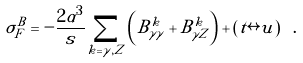Convert formula to latex. <formula><loc_0><loc_0><loc_500><loc_500>\sigma ^ { B } _ { F } = - \frac { 2 \alpha ^ { 3 } } { s } \sum _ { k = \gamma , Z } \left ( B _ { \gamma \gamma } ^ { k } + B _ { \gamma Z } ^ { k } \right ) + \left ( t \leftrightarrow u \right ) \ .</formula> 